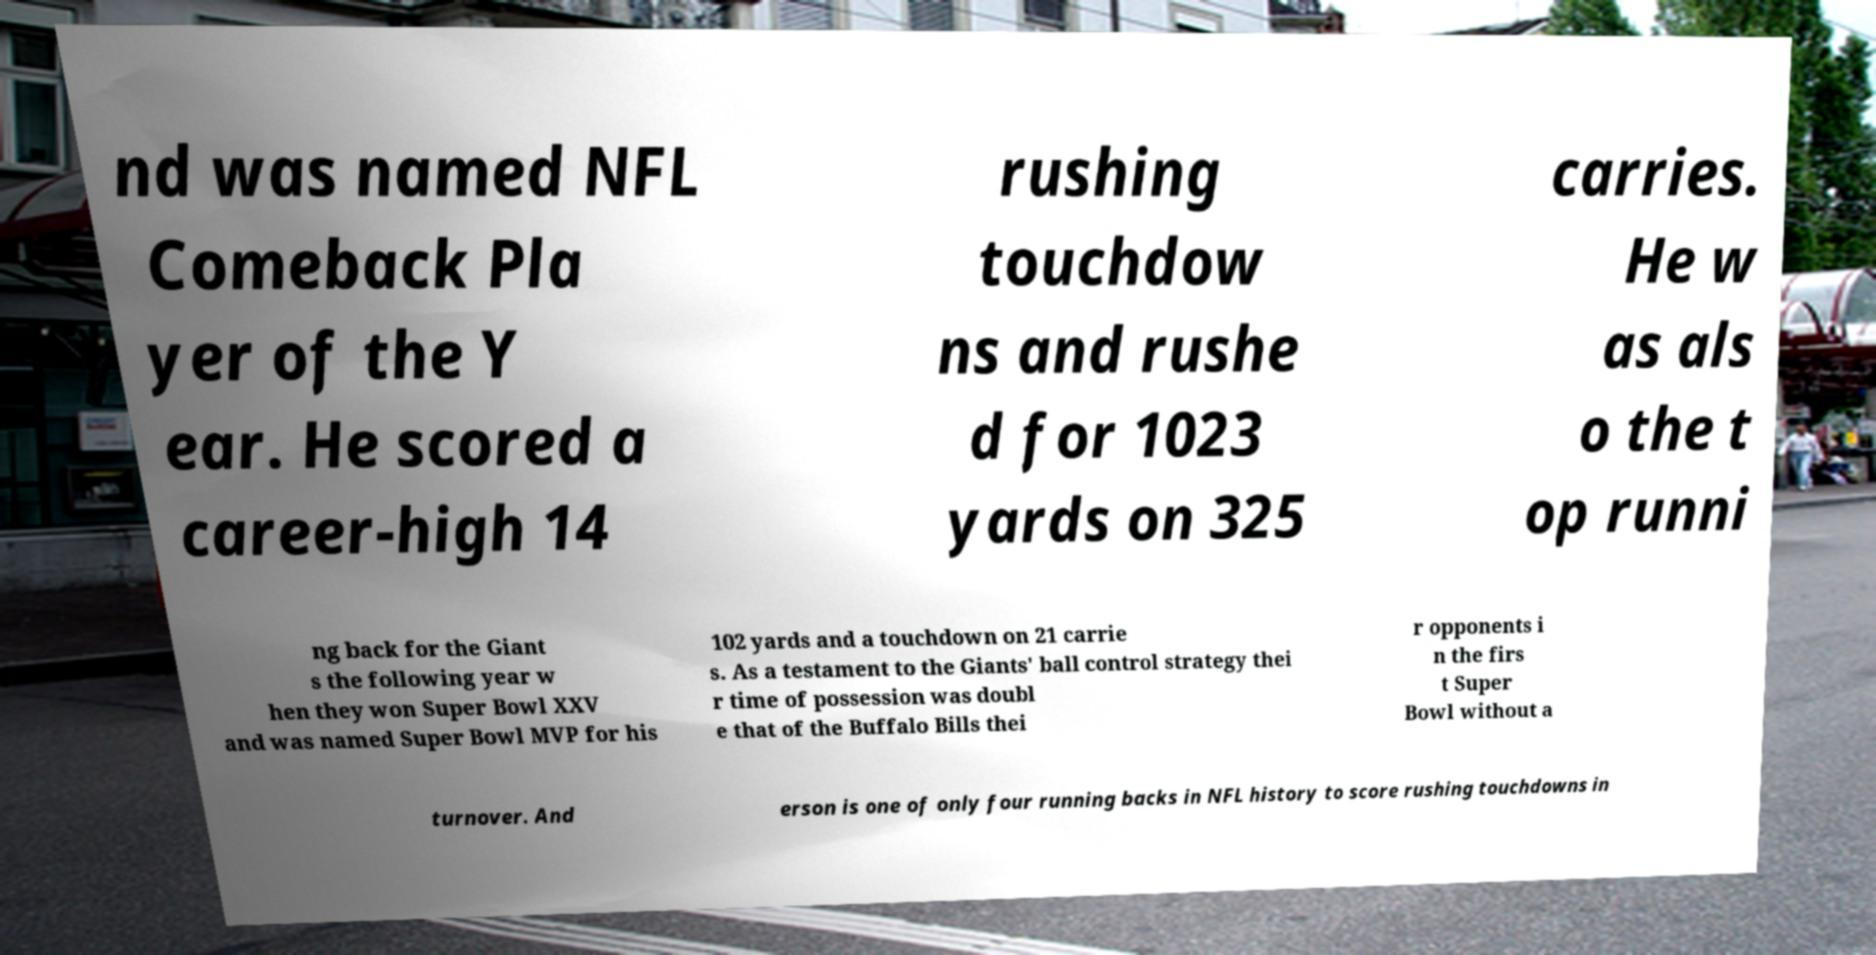There's text embedded in this image that I need extracted. Can you transcribe it verbatim? nd was named NFL Comeback Pla yer of the Y ear. He scored a career-high 14 rushing touchdow ns and rushe d for 1023 yards on 325 carries. He w as als o the t op runni ng back for the Giant s the following year w hen they won Super Bowl XXV and was named Super Bowl MVP for his 102 yards and a touchdown on 21 carrie s. As a testament to the Giants' ball control strategy thei r time of possession was doubl e that of the Buffalo Bills thei r opponents i n the firs t Super Bowl without a turnover. And erson is one of only four running backs in NFL history to score rushing touchdowns in 